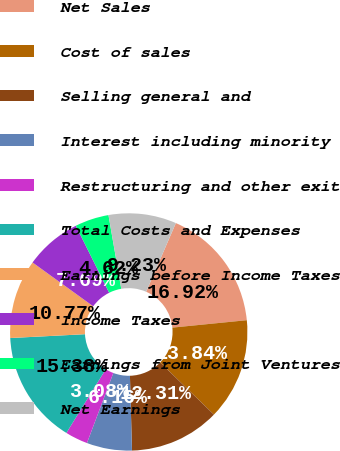Convert chart. <chart><loc_0><loc_0><loc_500><loc_500><pie_chart><fcel>Net Sales<fcel>Cost of sales<fcel>Selling general and<fcel>Interest including minority<fcel>Restructuring and other exit<fcel>Total Costs and Expenses<fcel>Earnings before Income Taxes<fcel>Income Taxes<fcel>Earnings from Joint Ventures<fcel>Net Earnings<nl><fcel>16.92%<fcel>13.84%<fcel>12.31%<fcel>6.16%<fcel>3.08%<fcel>15.38%<fcel>10.77%<fcel>7.69%<fcel>4.62%<fcel>9.23%<nl></chart> 